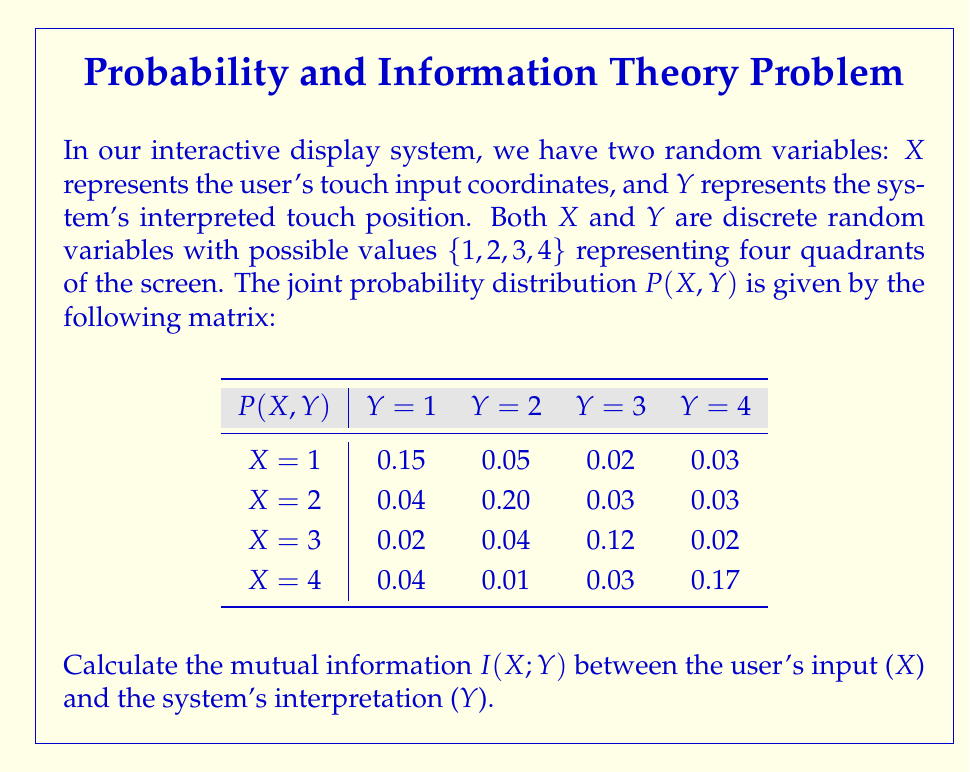Can you answer this question? To calculate the mutual information I(X;Y), we'll follow these steps:

1) First, we need to calculate the marginal probabilities P(X) and P(Y):

   P(X=1) = 0.15 + 0.05 + 0.02 + 0.03 = 0.25
   P(X=2) = 0.04 + 0.20 + 0.03 + 0.03 = 0.30
   P(X=3) = 0.02 + 0.04 + 0.12 + 0.02 = 0.20
   P(X=4) = 0.04 + 0.01 + 0.03 + 0.17 = 0.25

   P(Y=1) = 0.15 + 0.04 + 0.02 + 0.04 = 0.25
   P(Y=2) = 0.05 + 0.20 + 0.04 + 0.01 = 0.30
   P(Y=3) = 0.02 + 0.03 + 0.12 + 0.03 = 0.20
   P(Y=4) = 0.03 + 0.03 + 0.02 + 0.17 = 0.25

2) The formula for mutual information is:

   $$I(X;Y) = \sum_{x}\sum_{y} P(x,y) \log_2\frac{P(x,y)}{P(x)P(y)}$$

3) Let's calculate each term:

   For X=1, Y=1: $0.15 \log_2\frac{0.15}{0.25 * 0.25} = 0.15 \log_2 2.4 = 0.263$
   For X=1, Y=2: $0.05 \log_2\frac{0.05}{0.25 * 0.30} = 0.05 \log_2 0.667 = -0.025$
   ...
   For X=4, Y=4: $0.17 \log_2\frac{0.17}{0.25 * 0.25} = 0.17 \log_2 2.72 = 0.330$

4) Sum up all these terms:

   I(X;Y) = 0.263 + (-0.025) + ... + 0.330 = 0.736 bits
Answer: 0.736 bits 